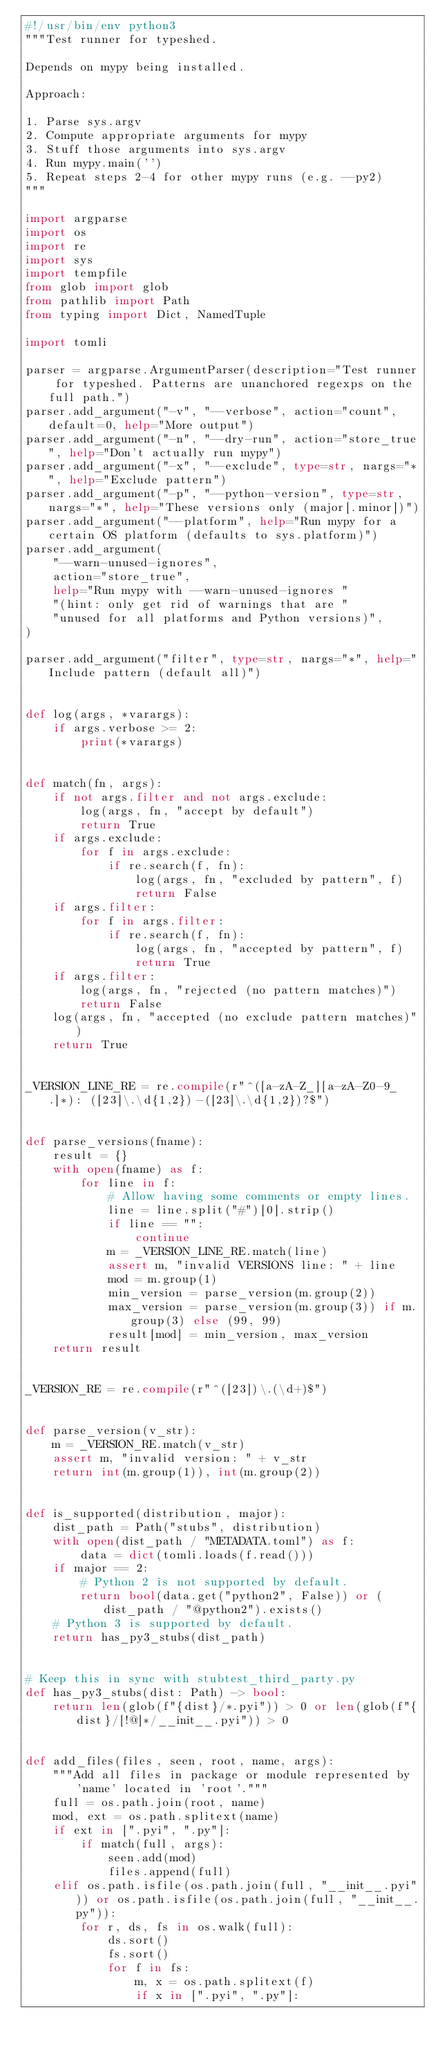<code> <loc_0><loc_0><loc_500><loc_500><_Python_>#!/usr/bin/env python3
"""Test runner for typeshed.

Depends on mypy being installed.

Approach:

1. Parse sys.argv
2. Compute appropriate arguments for mypy
3. Stuff those arguments into sys.argv
4. Run mypy.main('')
5. Repeat steps 2-4 for other mypy runs (e.g. --py2)
"""

import argparse
import os
import re
import sys
import tempfile
from glob import glob
from pathlib import Path
from typing import Dict, NamedTuple

import tomli

parser = argparse.ArgumentParser(description="Test runner for typeshed. Patterns are unanchored regexps on the full path.")
parser.add_argument("-v", "--verbose", action="count", default=0, help="More output")
parser.add_argument("-n", "--dry-run", action="store_true", help="Don't actually run mypy")
parser.add_argument("-x", "--exclude", type=str, nargs="*", help="Exclude pattern")
parser.add_argument("-p", "--python-version", type=str, nargs="*", help="These versions only (major[.minor])")
parser.add_argument("--platform", help="Run mypy for a certain OS platform (defaults to sys.platform)")
parser.add_argument(
    "--warn-unused-ignores",
    action="store_true",
    help="Run mypy with --warn-unused-ignores "
    "(hint: only get rid of warnings that are "
    "unused for all platforms and Python versions)",
)

parser.add_argument("filter", type=str, nargs="*", help="Include pattern (default all)")


def log(args, *varargs):
    if args.verbose >= 2:
        print(*varargs)


def match(fn, args):
    if not args.filter and not args.exclude:
        log(args, fn, "accept by default")
        return True
    if args.exclude:
        for f in args.exclude:
            if re.search(f, fn):
                log(args, fn, "excluded by pattern", f)
                return False
    if args.filter:
        for f in args.filter:
            if re.search(f, fn):
                log(args, fn, "accepted by pattern", f)
                return True
    if args.filter:
        log(args, fn, "rejected (no pattern matches)")
        return False
    log(args, fn, "accepted (no exclude pattern matches)")
    return True


_VERSION_LINE_RE = re.compile(r"^([a-zA-Z_][a-zA-Z0-9_.]*): ([23]\.\d{1,2})-([23]\.\d{1,2})?$")


def parse_versions(fname):
    result = {}
    with open(fname) as f:
        for line in f:
            # Allow having some comments or empty lines.
            line = line.split("#")[0].strip()
            if line == "":
                continue
            m = _VERSION_LINE_RE.match(line)
            assert m, "invalid VERSIONS line: " + line
            mod = m.group(1)
            min_version = parse_version(m.group(2))
            max_version = parse_version(m.group(3)) if m.group(3) else (99, 99)
            result[mod] = min_version, max_version
    return result


_VERSION_RE = re.compile(r"^([23])\.(\d+)$")


def parse_version(v_str):
    m = _VERSION_RE.match(v_str)
    assert m, "invalid version: " + v_str
    return int(m.group(1)), int(m.group(2))


def is_supported(distribution, major):
    dist_path = Path("stubs", distribution)
    with open(dist_path / "METADATA.toml") as f:
        data = dict(tomli.loads(f.read()))
    if major == 2:
        # Python 2 is not supported by default.
        return bool(data.get("python2", False)) or (dist_path / "@python2").exists()
    # Python 3 is supported by default.
    return has_py3_stubs(dist_path)


# Keep this in sync with stubtest_third_party.py
def has_py3_stubs(dist: Path) -> bool:
    return len(glob(f"{dist}/*.pyi")) > 0 or len(glob(f"{dist}/[!@]*/__init__.pyi")) > 0


def add_files(files, seen, root, name, args):
    """Add all files in package or module represented by 'name' located in 'root'."""
    full = os.path.join(root, name)
    mod, ext = os.path.splitext(name)
    if ext in [".pyi", ".py"]:
        if match(full, args):
            seen.add(mod)
            files.append(full)
    elif os.path.isfile(os.path.join(full, "__init__.pyi")) or os.path.isfile(os.path.join(full, "__init__.py")):
        for r, ds, fs in os.walk(full):
            ds.sort()
            fs.sort()
            for f in fs:
                m, x = os.path.splitext(f)
                if x in [".pyi", ".py"]:</code> 